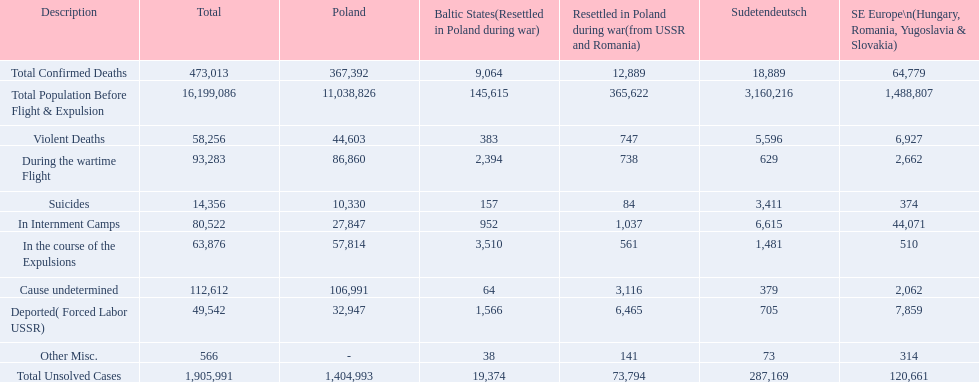What are the numbers of violent deaths across the area? 44,603, 383, 747, 5,596, 6,927. What is the total number of violent deaths of the area? 58,256. 